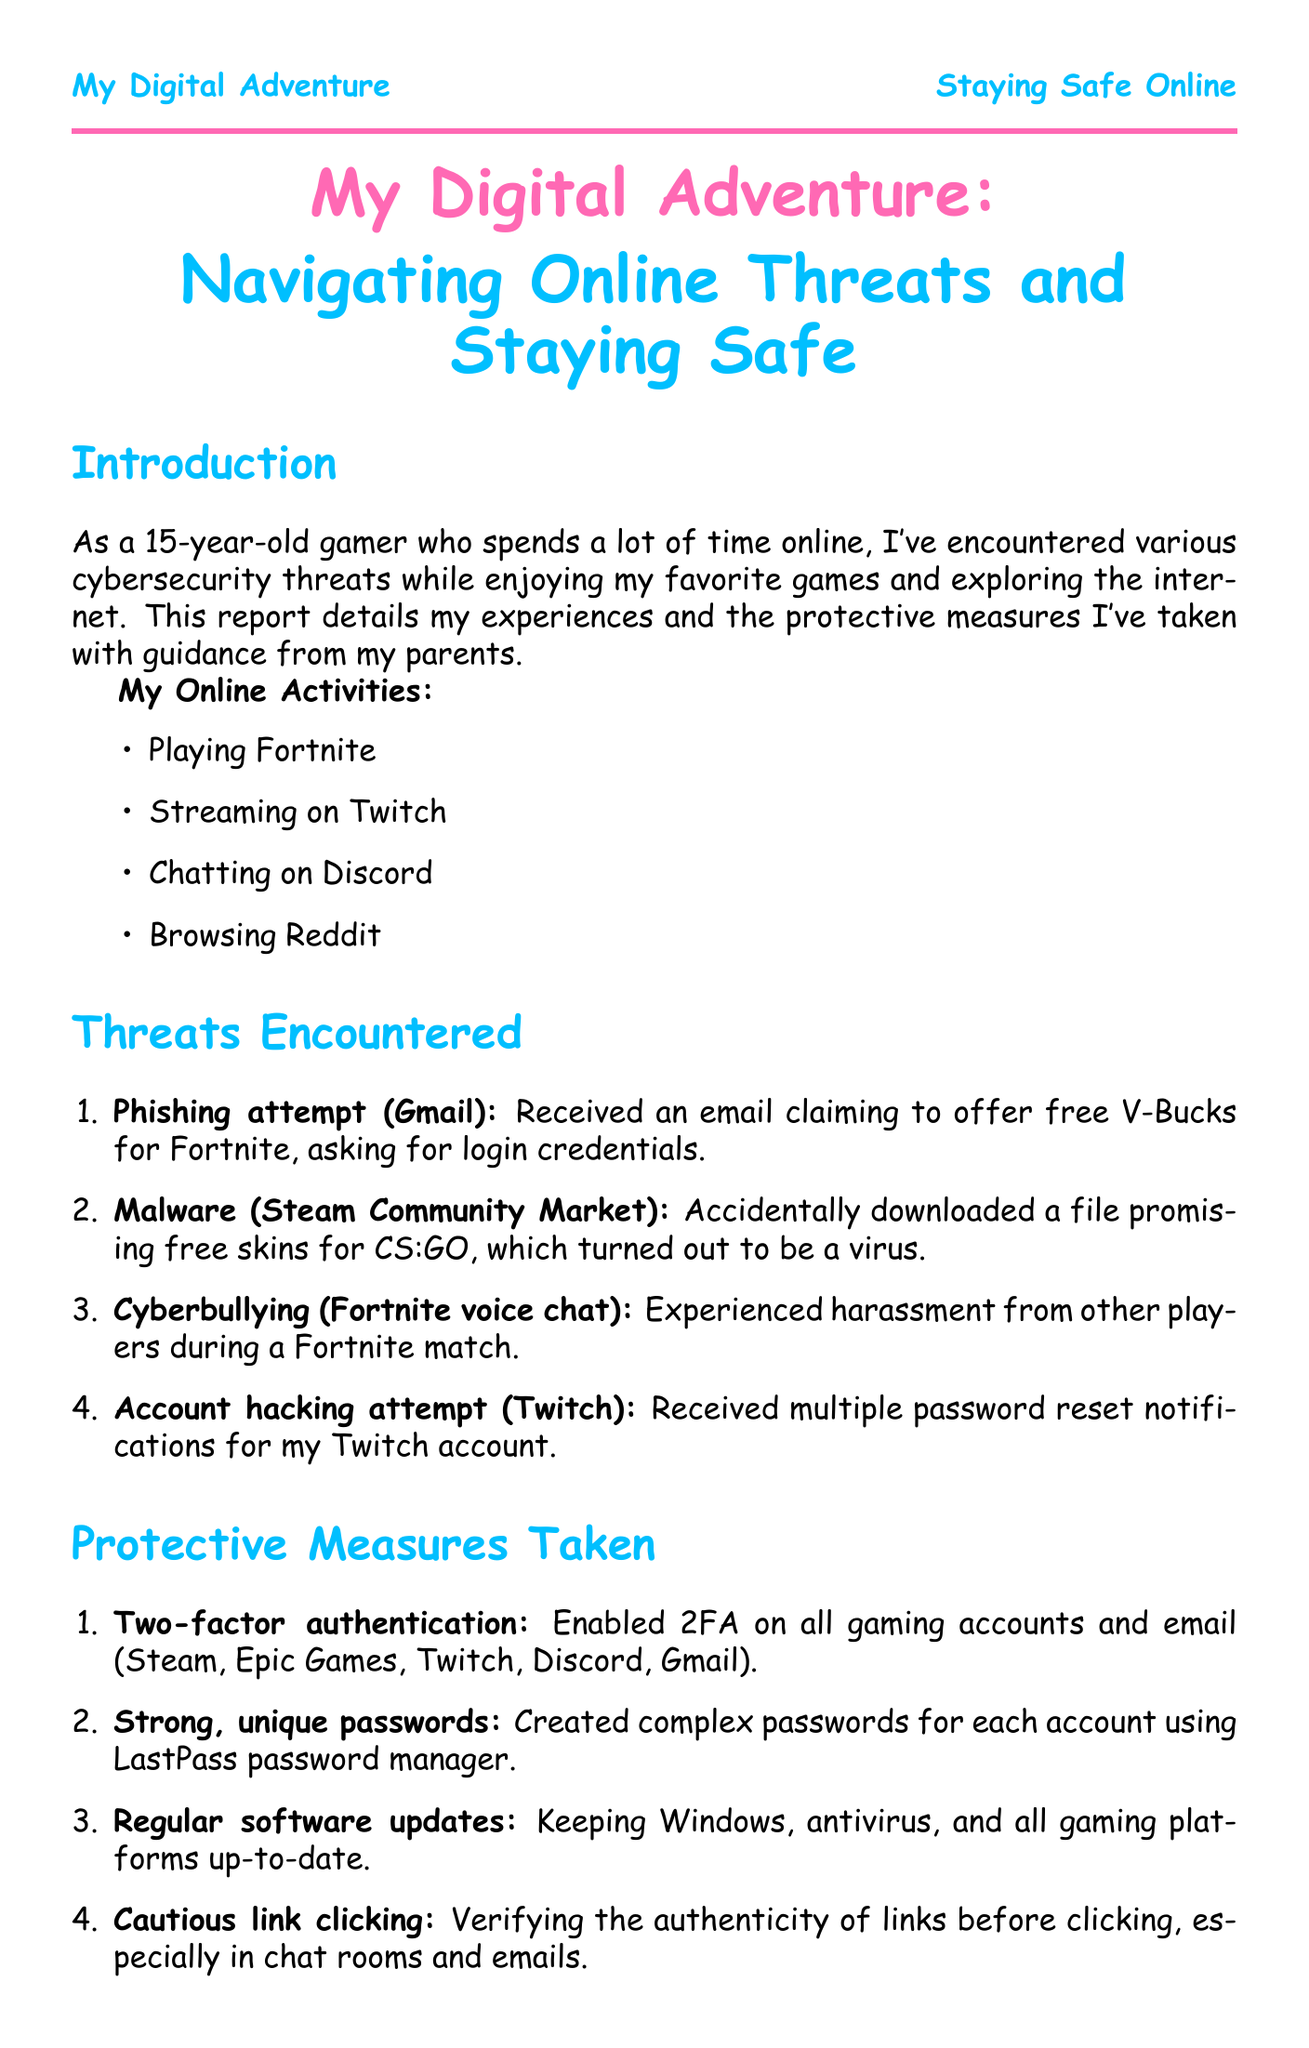What is the age of the author? The age of the author is explicitly stated in the introduction of the document.
Answer: 15 What online activity was reported as experiencing harassment? This activity is mentioned under the threats encountered section that discusses harassment during a game.
Answer: Fortnite match What is the first protective measure taken? The first protective measure listed indicates what security feature was implemented for gaming accounts.
Answer: Two-factor authentication What tool is used for creating unique passwords? The document specifies a tool used for password management.
Answer: LastPass How many threats were encountered? The number of threats is counted in the threats encountered section.
Answer: Four What was the parental advice regarding online stranger danger? The documented advice relates to interactions with unknown individuals online.
Answer: Don't share personal information What future plan involves learning about security? The future plans detail aspirations related to security education.
Answer: Learn more about ethical hacking What action was taken regarding in-game purchases? This action refers to how purchases are managed to ensure parental oversight.
Answer: Set up purchase approvals What lesson emphasizes the importance of software updates? The lessons section includes a specific reminder about maintaining software.
Answer: Keeping software updated is crucial for protection against new threats 